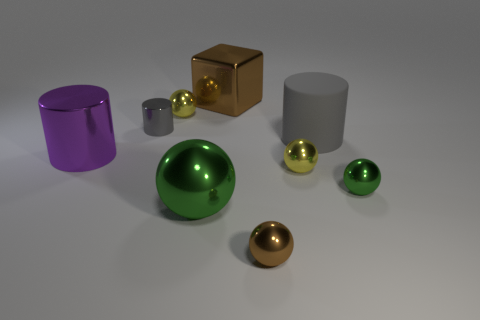What number of matte objects are either small cylinders or yellow things?
Provide a succinct answer. 0. Are there more brown objects that are in front of the purple metal thing than red balls?
Ensure brevity in your answer.  Yes. What is the material of the green sphere that is right of the large brown block?
Ensure brevity in your answer.  Metal. What number of small gray cylinders have the same material as the purple cylinder?
Offer a terse response. 1. What shape is the thing that is both in front of the tiny green metallic sphere and behind the brown metallic ball?
Offer a very short reply. Sphere. How many things are either yellow metallic things right of the small brown ball or metallic things in front of the big brown shiny block?
Offer a terse response. 7. Are there the same number of brown cubes in front of the tiny gray object and big metal cylinders that are in front of the large brown object?
Offer a terse response. No. What is the shape of the brown thing that is behind the large cylinder to the left of the large gray rubber cylinder?
Your answer should be compact. Cube. Is there another small green object of the same shape as the rubber object?
Provide a short and direct response. No. How many brown rubber balls are there?
Provide a short and direct response. 0. 